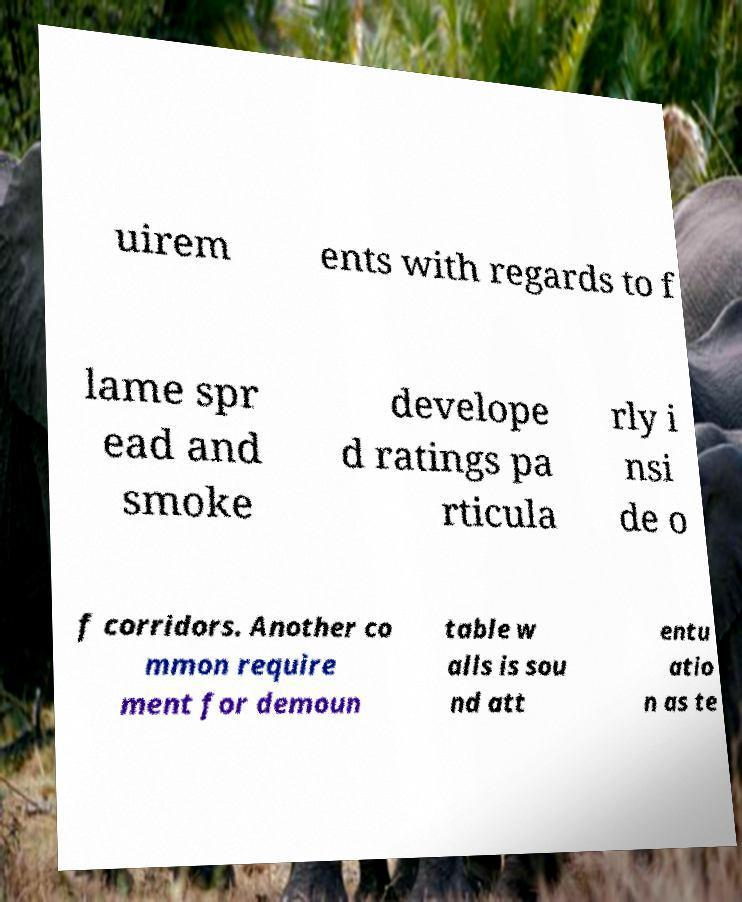Please read and relay the text visible in this image. What does it say? uirem ents with regards to f lame spr ead and smoke develope d ratings pa rticula rly i nsi de o f corridors. Another co mmon require ment for demoun table w alls is sou nd att entu atio n as te 